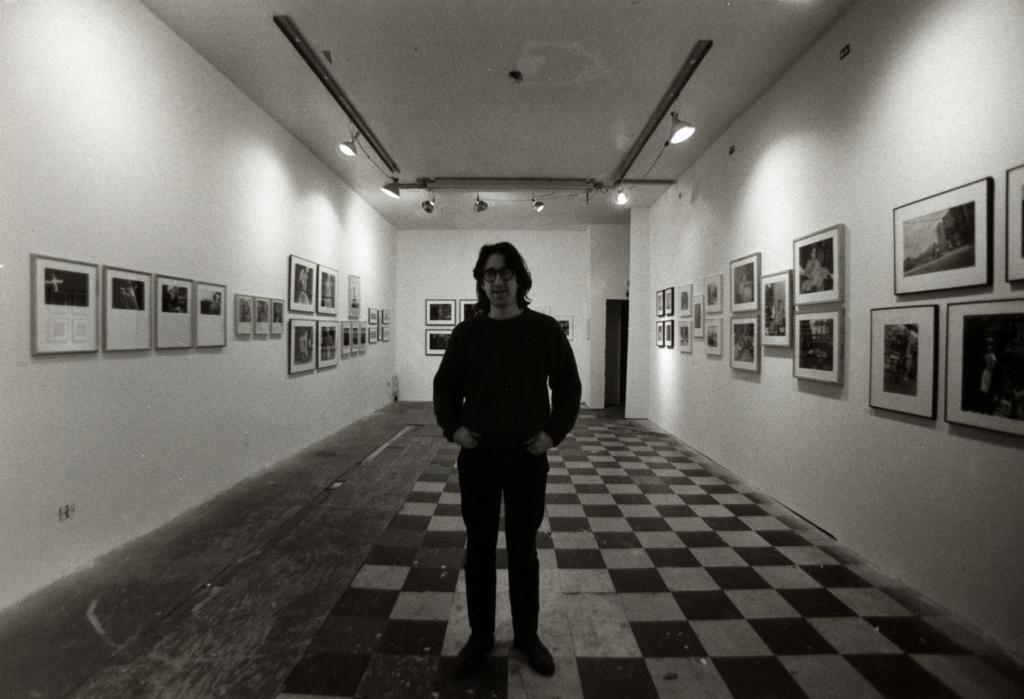Can you describe this image briefly? In this picture we can see a person standing here, on the right side and left side there are some photo frames, in the background there is a wall, we can see some lights here. 